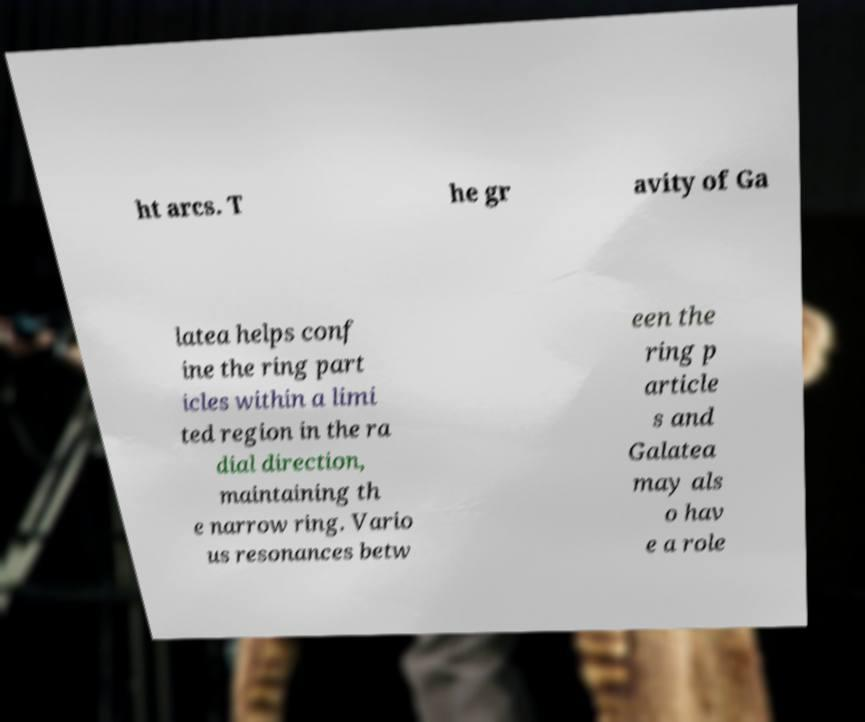Can you read and provide the text displayed in the image?This photo seems to have some interesting text. Can you extract and type it out for me? ht arcs. T he gr avity of Ga latea helps conf ine the ring part icles within a limi ted region in the ra dial direction, maintaining th e narrow ring. Vario us resonances betw een the ring p article s and Galatea may als o hav e a role 